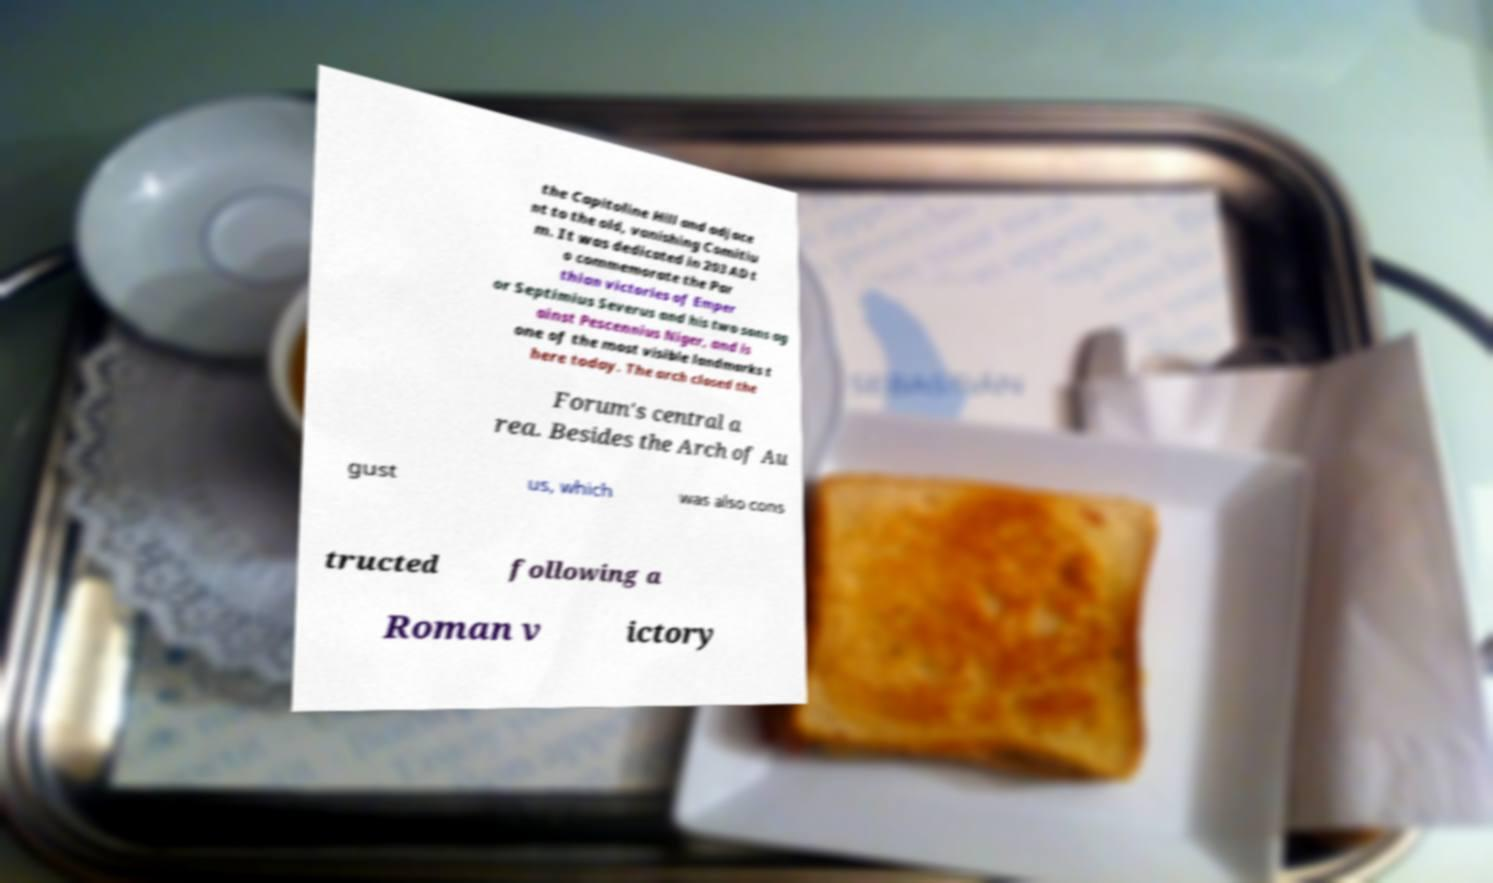Could you extract and type out the text from this image? the Capitoline Hill and adjace nt to the old, vanishing Comitiu m. It was dedicated in 203 AD t o commemorate the Par thian victories of Emper or Septimius Severus and his two sons ag ainst Pescennius Niger, and is one of the most visible landmarks t here today. The arch closed the Forum's central a rea. Besides the Arch of Au gust us, which was also cons tructed following a Roman v ictory 